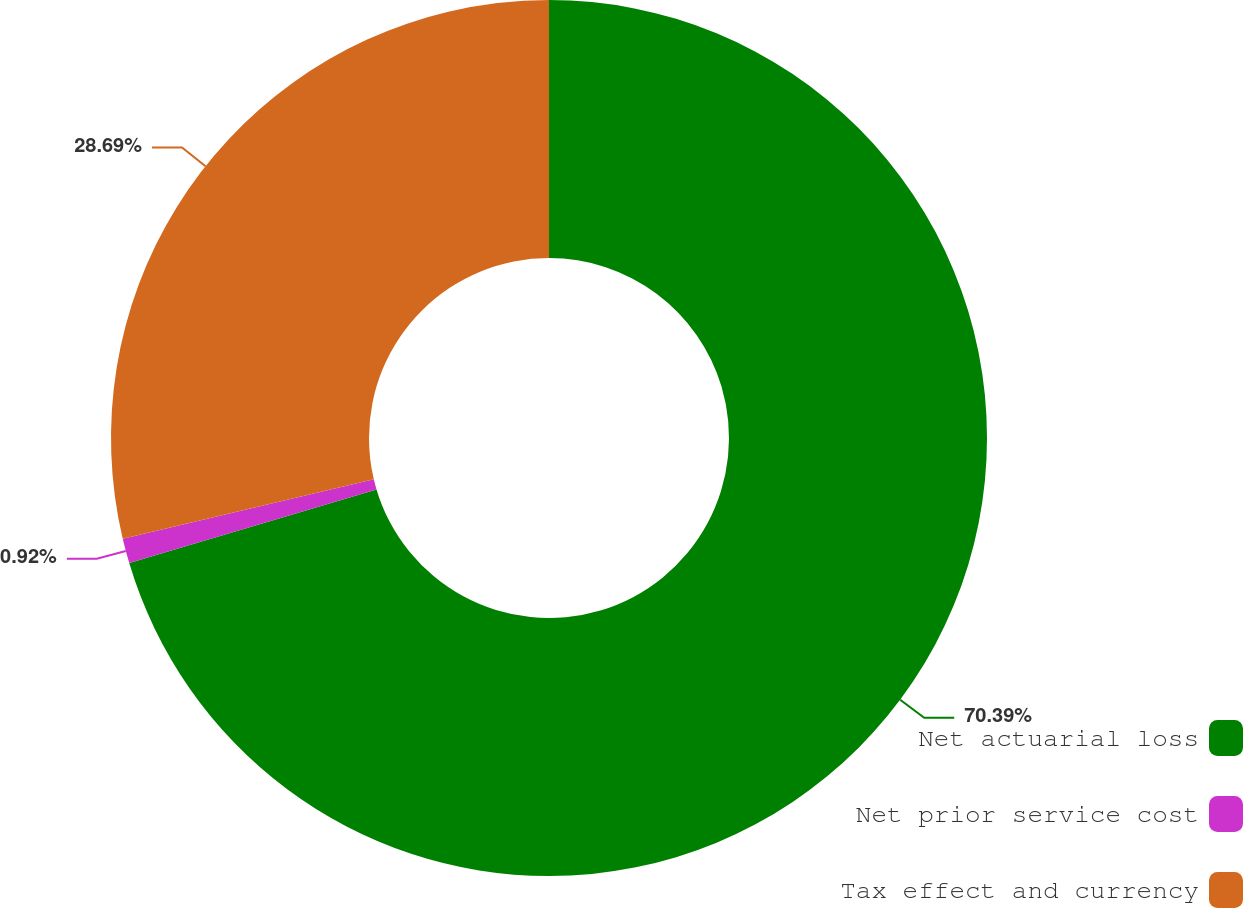<chart> <loc_0><loc_0><loc_500><loc_500><pie_chart><fcel>Net actuarial loss<fcel>Net prior service cost<fcel>Tax effect and currency<nl><fcel>70.39%<fcel>0.92%<fcel>28.69%<nl></chart> 